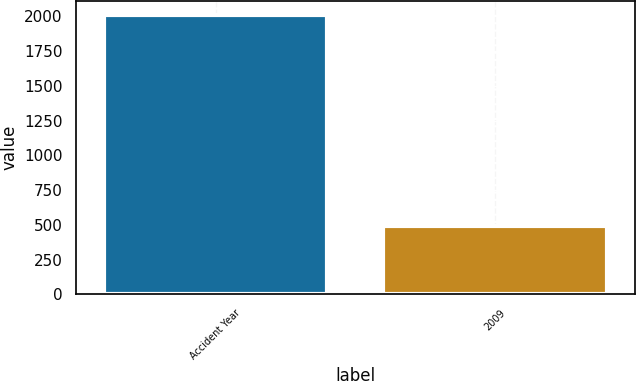Convert chart. <chart><loc_0><loc_0><loc_500><loc_500><bar_chart><fcel>Accident Year<fcel>2009<nl><fcel>2009<fcel>492<nl></chart> 